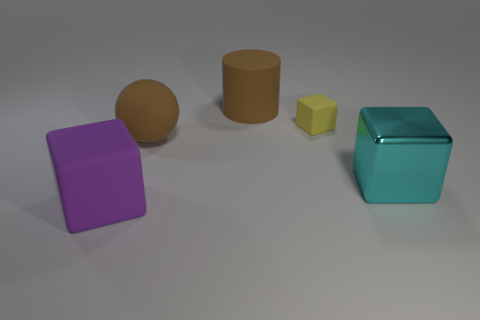Are there any other things that are made of the same material as the cyan object?
Your answer should be very brief. No. How many objects are both behind the big brown rubber ball and in front of the big cyan cube?
Your answer should be very brief. 0. How many yellow blocks have the same material as the large cyan cube?
Make the answer very short. 0. There is a tiny object that is the same material as the large purple object; what is its color?
Make the answer very short. Yellow. Are there fewer red metallic balls than tiny things?
Ensure brevity in your answer.  Yes. What material is the thing that is behind the block that is behind the large block behind the big purple matte block made of?
Make the answer very short. Rubber. What is the yellow object made of?
Provide a short and direct response. Rubber. Is the color of the object that is behind the yellow rubber block the same as the big sphere that is on the left side of the large rubber cylinder?
Offer a very short reply. Yes. Are there more brown matte cylinders than blue matte spheres?
Give a very brief answer. Yes. What number of objects are the same color as the large rubber sphere?
Provide a short and direct response. 1. 